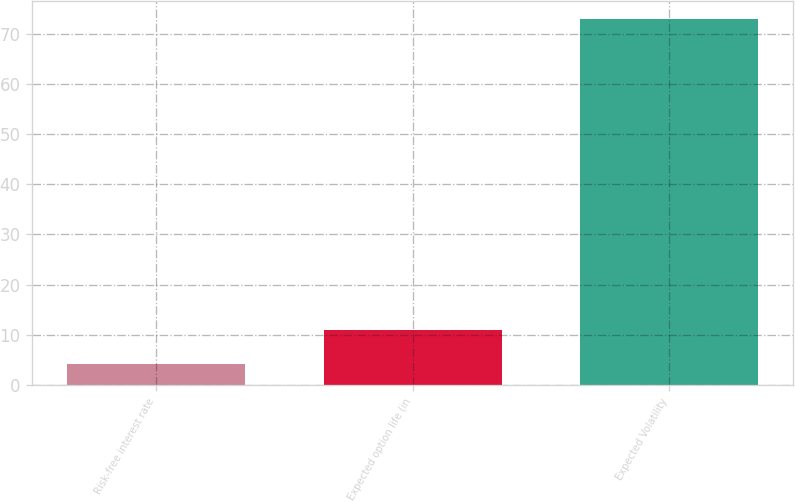Convert chart. <chart><loc_0><loc_0><loc_500><loc_500><bar_chart><fcel>Risk-free interest rate<fcel>Expected option life (in<fcel>Expected Volatility<nl><fcel>4.14<fcel>11.03<fcel>73<nl></chart> 